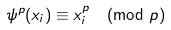<formula> <loc_0><loc_0><loc_500><loc_500>\psi ^ { p } ( x _ { i } ) \equiv x _ { i } ^ { p } \pmod { p }</formula> 